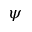Convert formula to latex. <formula><loc_0><loc_0><loc_500><loc_500>\psi</formula> 